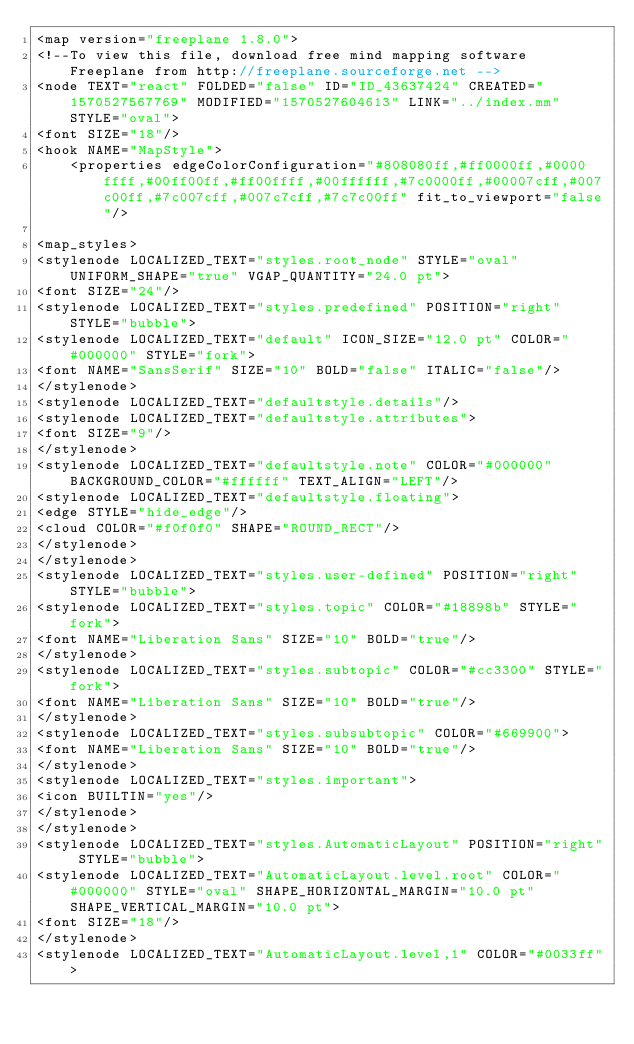Convert code to text. <code><loc_0><loc_0><loc_500><loc_500><_ObjectiveC_><map version="freeplane 1.8.0">
<!--To view this file, download free mind mapping software Freeplane from http://freeplane.sourceforge.net -->
<node TEXT="react" FOLDED="false" ID="ID_43637424" CREATED="1570527567769" MODIFIED="1570527604613" LINK="../index.mm" STYLE="oval">
<font SIZE="18"/>
<hook NAME="MapStyle">
    <properties edgeColorConfiguration="#808080ff,#ff0000ff,#0000ffff,#00ff00ff,#ff00ffff,#00ffffff,#7c0000ff,#00007cff,#007c00ff,#7c007cff,#007c7cff,#7c7c00ff" fit_to_viewport="false"/>

<map_styles>
<stylenode LOCALIZED_TEXT="styles.root_node" STYLE="oval" UNIFORM_SHAPE="true" VGAP_QUANTITY="24.0 pt">
<font SIZE="24"/>
<stylenode LOCALIZED_TEXT="styles.predefined" POSITION="right" STYLE="bubble">
<stylenode LOCALIZED_TEXT="default" ICON_SIZE="12.0 pt" COLOR="#000000" STYLE="fork">
<font NAME="SansSerif" SIZE="10" BOLD="false" ITALIC="false"/>
</stylenode>
<stylenode LOCALIZED_TEXT="defaultstyle.details"/>
<stylenode LOCALIZED_TEXT="defaultstyle.attributes">
<font SIZE="9"/>
</stylenode>
<stylenode LOCALIZED_TEXT="defaultstyle.note" COLOR="#000000" BACKGROUND_COLOR="#ffffff" TEXT_ALIGN="LEFT"/>
<stylenode LOCALIZED_TEXT="defaultstyle.floating">
<edge STYLE="hide_edge"/>
<cloud COLOR="#f0f0f0" SHAPE="ROUND_RECT"/>
</stylenode>
</stylenode>
<stylenode LOCALIZED_TEXT="styles.user-defined" POSITION="right" STYLE="bubble">
<stylenode LOCALIZED_TEXT="styles.topic" COLOR="#18898b" STYLE="fork">
<font NAME="Liberation Sans" SIZE="10" BOLD="true"/>
</stylenode>
<stylenode LOCALIZED_TEXT="styles.subtopic" COLOR="#cc3300" STYLE="fork">
<font NAME="Liberation Sans" SIZE="10" BOLD="true"/>
</stylenode>
<stylenode LOCALIZED_TEXT="styles.subsubtopic" COLOR="#669900">
<font NAME="Liberation Sans" SIZE="10" BOLD="true"/>
</stylenode>
<stylenode LOCALIZED_TEXT="styles.important">
<icon BUILTIN="yes"/>
</stylenode>
</stylenode>
<stylenode LOCALIZED_TEXT="styles.AutomaticLayout" POSITION="right" STYLE="bubble">
<stylenode LOCALIZED_TEXT="AutomaticLayout.level.root" COLOR="#000000" STYLE="oval" SHAPE_HORIZONTAL_MARGIN="10.0 pt" SHAPE_VERTICAL_MARGIN="10.0 pt">
<font SIZE="18"/>
</stylenode>
<stylenode LOCALIZED_TEXT="AutomaticLayout.level,1" COLOR="#0033ff"></code> 